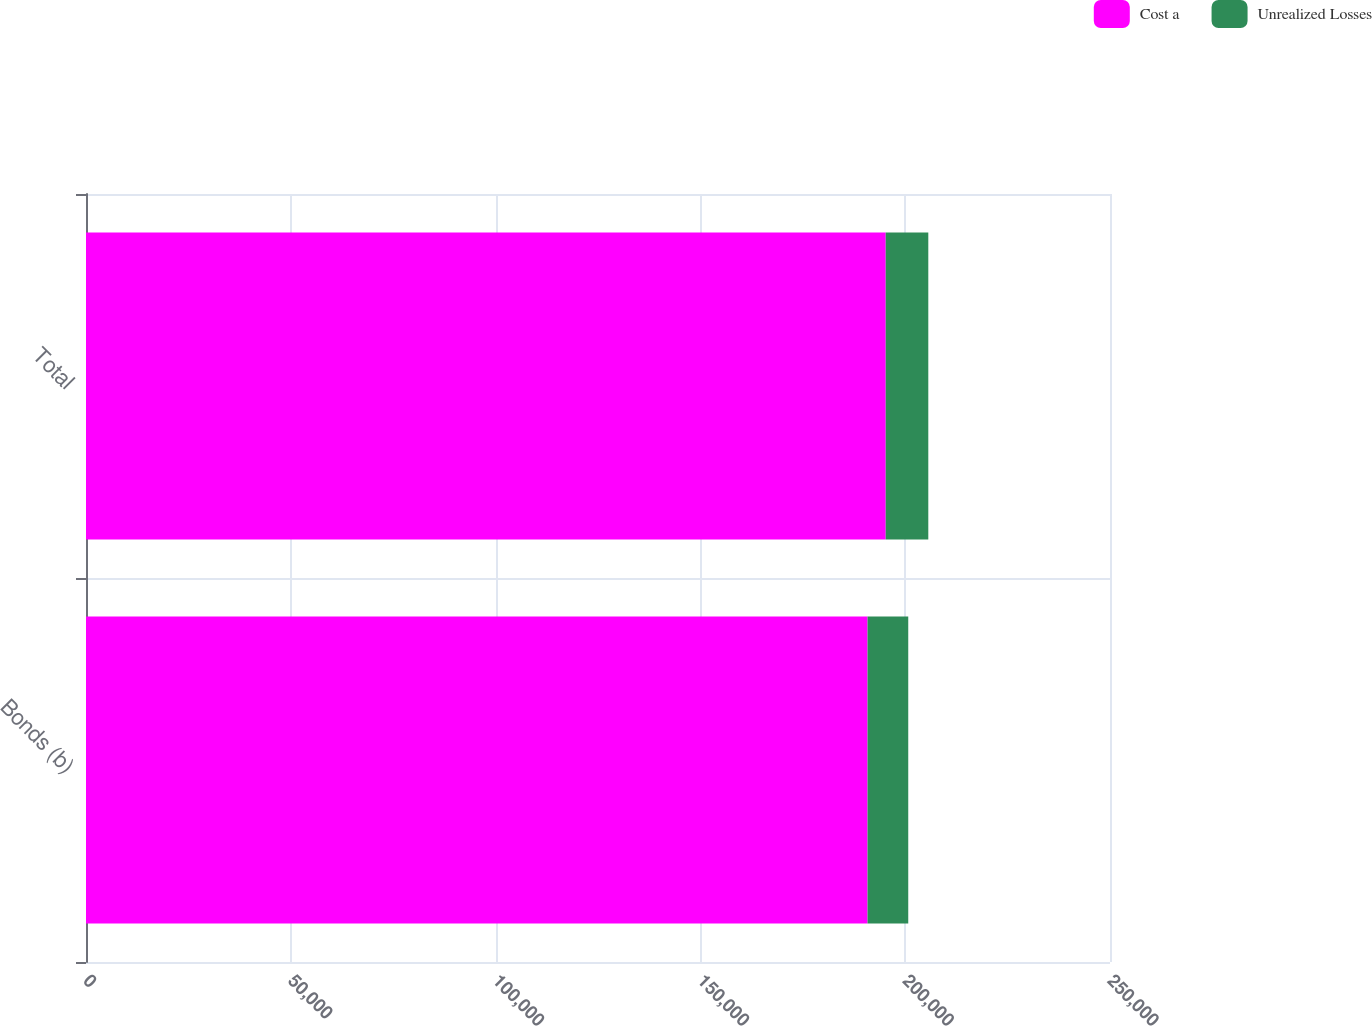Convert chart to OTSL. <chart><loc_0><loc_0><loc_500><loc_500><stacked_bar_chart><ecel><fcel>Bonds (b)<fcel>Total<nl><fcel>Cost a<fcel>190809<fcel>195242<nl><fcel>Unrealized Losses<fcel>9935<fcel>10398<nl></chart> 